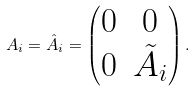<formula> <loc_0><loc_0><loc_500><loc_500>A _ { i } = \hat { A } _ { i } = \begin{pmatrix} 0 & 0 \\ 0 & \tilde { A } _ { i } \end{pmatrix} .</formula> 